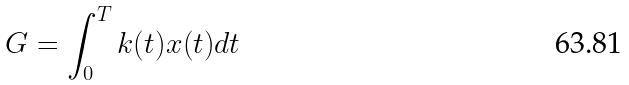Convert formula to latex. <formula><loc_0><loc_0><loc_500><loc_500>G = \int _ { 0 } ^ { T } k ( t ) x ( t ) d t</formula> 